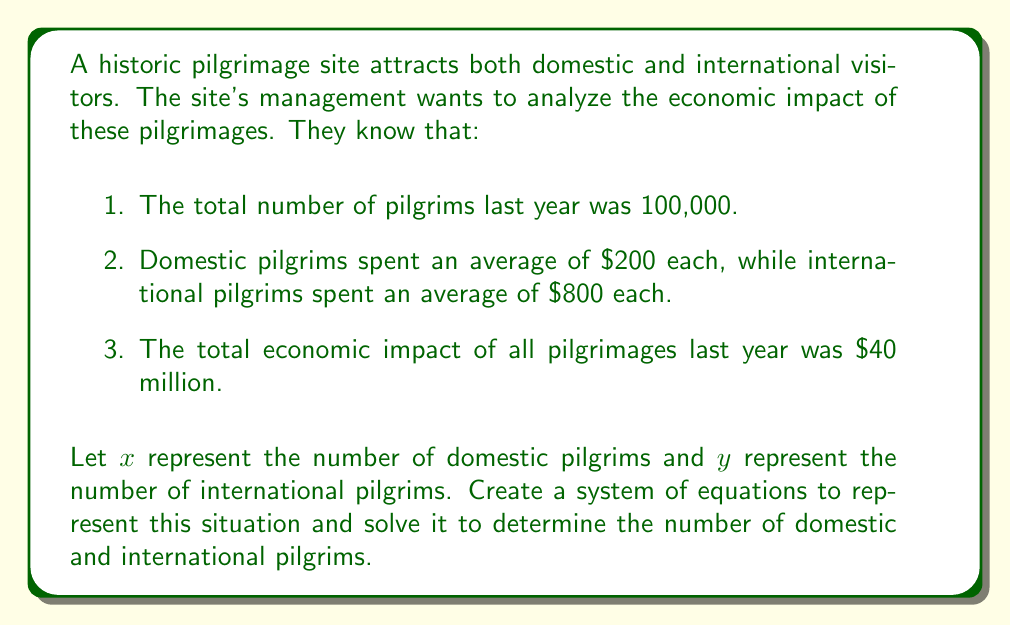What is the answer to this math problem? Let's approach this step-by-step:

1) First, we need to set up our system of equations based on the given information:

   Equation 1: Total number of pilgrims
   $$x + y = 100,000$$

   Equation 2: Total economic impact
   $$200x + 800y = 40,000,000$$

2) Now we have a system of two equations with two unknowns:

   $$\begin{cases}
   x + y = 100,000 \\
   200x + 800y = 40,000,000
   \end{cases}$$

3) Let's solve this system using substitution. From the first equation:
   $$x = 100,000 - y$$

4) Substitute this into the second equation:
   $$200(100,000 - y) + 800y = 40,000,000$$

5) Simplify:
   $$20,000,000 - 200y + 800y = 40,000,000$$
   $$20,000,000 + 600y = 40,000,000$$

6) Solve for $y$:
   $$600y = 20,000,000$$
   $$y = 33,333.33$$

   Since we can't have a fractional number of pilgrims, we round down to 33,333.

7) Now substitute this value of $y$ back into the equation from step 3:
   $$x = 100,000 - 33,333 = 66,667$$

Therefore, there were 66,667 domestic pilgrims and 33,333 international pilgrims.
Answer: 66,667 domestic pilgrims, 33,333 international pilgrims 